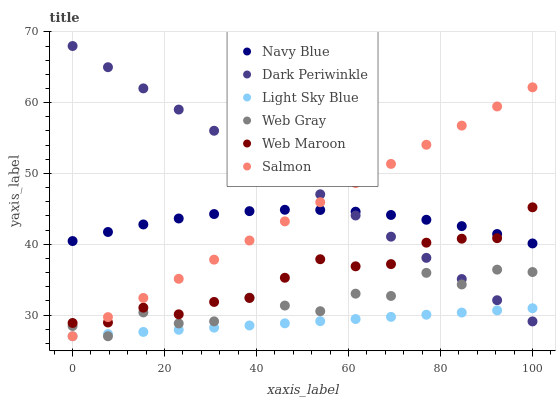Does Light Sky Blue have the minimum area under the curve?
Answer yes or no. Yes. Does Dark Periwinkle have the maximum area under the curve?
Answer yes or no. Yes. Does Navy Blue have the minimum area under the curve?
Answer yes or no. No. Does Navy Blue have the maximum area under the curve?
Answer yes or no. No. Is Light Sky Blue the smoothest?
Answer yes or no. Yes. Is Web Gray the roughest?
Answer yes or no. Yes. Is Navy Blue the smoothest?
Answer yes or no. No. Is Navy Blue the roughest?
Answer yes or no. No. Does Web Gray have the lowest value?
Answer yes or no. Yes. Does Web Maroon have the lowest value?
Answer yes or no. No. Does Dark Periwinkle have the highest value?
Answer yes or no. Yes. Does Navy Blue have the highest value?
Answer yes or no. No. Is Light Sky Blue less than Web Maroon?
Answer yes or no. Yes. Is Navy Blue greater than Light Sky Blue?
Answer yes or no. Yes. Does Dark Periwinkle intersect Salmon?
Answer yes or no. Yes. Is Dark Periwinkle less than Salmon?
Answer yes or no. No. Is Dark Periwinkle greater than Salmon?
Answer yes or no. No. Does Light Sky Blue intersect Web Maroon?
Answer yes or no. No. 